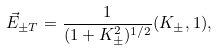<formula> <loc_0><loc_0><loc_500><loc_500>\vec { E } _ { \pm T } = \frac { 1 } { ( 1 + K _ { \pm } ^ { 2 } ) ^ { 1 / 2 } } ( K _ { \pm } , 1 ) ,</formula> 